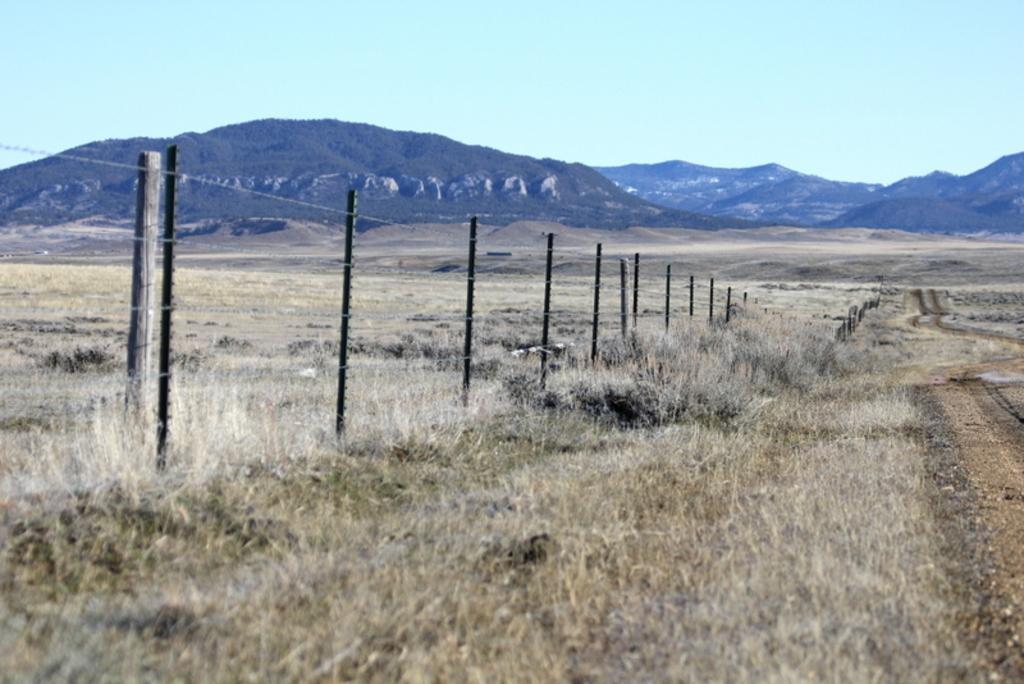Describe this image in one or two sentences. This picture shows grass on the ground and we see fence and we see hills and trees and a blue cloudy sky. 